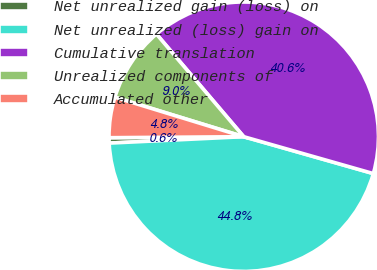Convert chart. <chart><loc_0><loc_0><loc_500><loc_500><pie_chart><fcel>Net unrealized gain (loss) on<fcel>Net unrealized (loss) gain on<fcel>Cumulative translation<fcel>Unrealized components of<fcel>Accumulated other<nl><fcel>0.64%<fcel>44.83%<fcel>40.63%<fcel>9.05%<fcel>4.85%<nl></chart> 